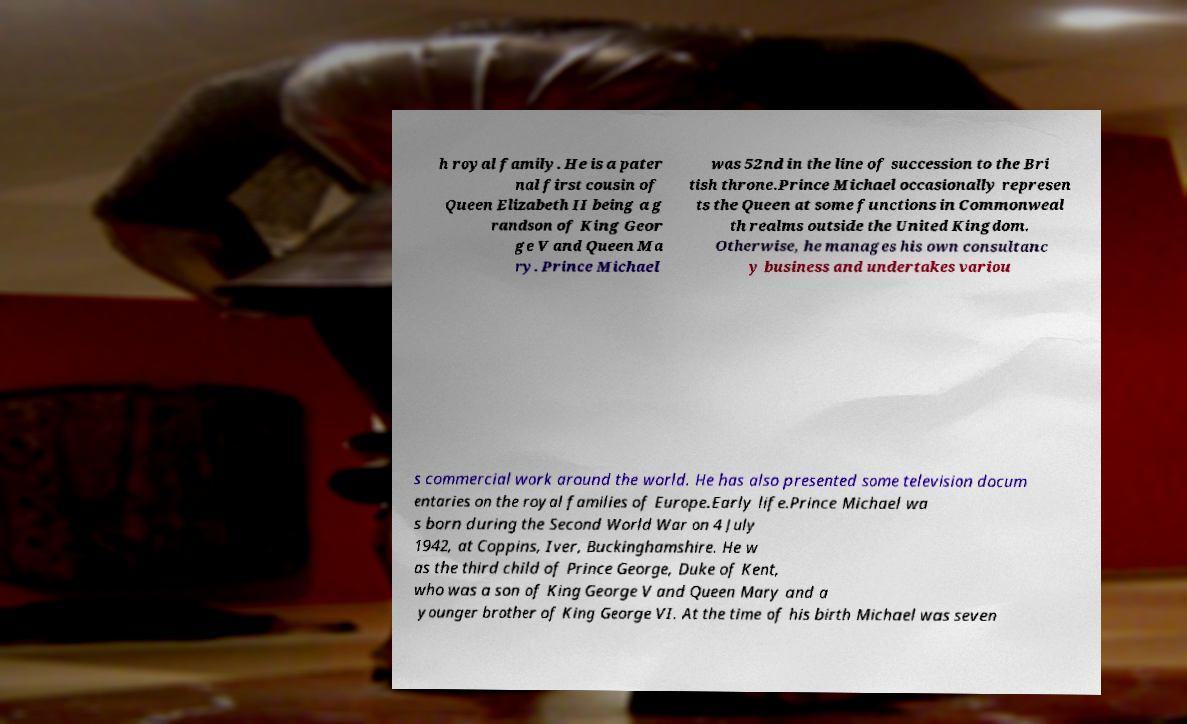Please identify and transcribe the text found in this image. h royal family. He is a pater nal first cousin of Queen Elizabeth II being a g randson of King Geor ge V and Queen Ma ry. Prince Michael was 52nd in the line of succession to the Bri tish throne.Prince Michael occasionally represen ts the Queen at some functions in Commonweal th realms outside the United Kingdom. Otherwise, he manages his own consultanc y business and undertakes variou s commercial work around the world. He has also presented some television docum entaries on the royal families of Europe.Early life.Prince Michael wa s born during the Second World War on 4 July 1942, at Coppins, Iver, Buckinghamshire. He w as the third child of Prince George, Duke of Kent, who was a son of King George V and Queen Mary and a younger brother of King George VI. At the time of his birth Michael was seven 